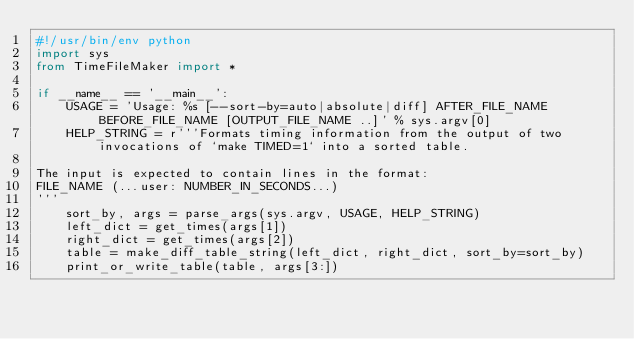<code> <loc_0><loc_0><loc_500><loc_500><_Python_>#!/usr/bin/env python
import sys
from TimeFileMaker import *

if __name__ == '__main__':
    USAGE = 'Usage: %s [--sort-by=auto|absolute|diff] AFTER_FILE_NAME BEFORE_FILE_NAME [OUTPUT_FILE_NAME ..]' % sys.argv[0]
    HELP_STRING = r'''Formats timing information from the output of two invocations of `make TIMED=1` into a sorted table.

The input is expected to contain lines in the format:
FILE_NAME (...user: NUMBER_IN_SECONDS...)
'''
    sort_by, args = parse_args(sys.argv, USAGE, HELP_STRING)
    left_dict = get_times(args[1])
    right_dict = get_times(args[2])
    table = make_diff_table_string(left_dict, right_dict, sort_by=sort_by)
    print_or_write_table(table, args[3:])
</code> 